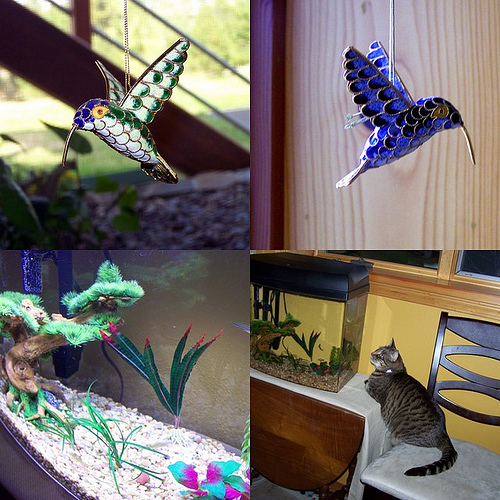Looking at the bottom images, what do you think the cat might be thinking or feeling? While we cannot know exactly what a cat is thinking, based on the image, the cat appears to be attentively observing the fish in the aquarium, showing a natural predatory interest. Its body language, with a straight and focused posture, suggests a mix of curiosity and concentration, reflecting the instinctive behaviors cats exhibit when they spot potential prey, even if just for entertainment. 